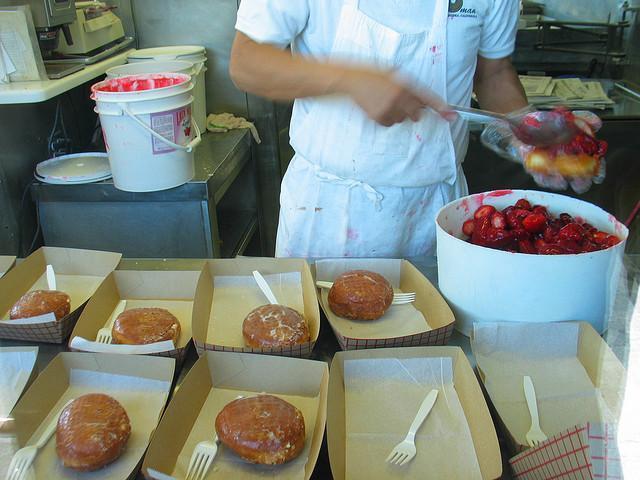What type of filling is in the donuts?
Choose the right answer from the provided options to respond to the question.
Options: Icing, custard, chocolate, fruit. Fruit. 